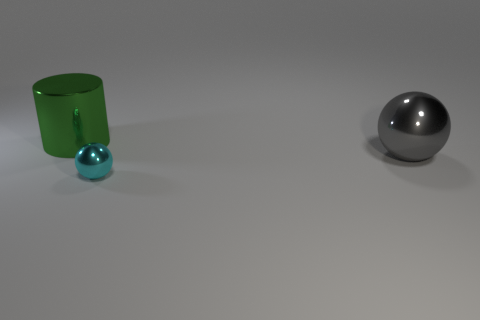Add 1 gray metal things. How many objects exist? 4 Subtract all cylinders. How many objects are left? 2 Subtract 0 gray blocks. How many objects are left? 3 Subtract 2 spheres. How many spheres are left? 0 Subtract all red spheres. Subtract all brown cylinders. How many spheres are left? 2 Subtract all brown cylinders. How many cyan balls are left? 1 Subtract all small green metallic balls. Subtract all tiny cyan objects. How many objects are left? 2 Add 3 big green cylinders. How many big green cylinders are left? 4 Add 2 big red spheres. How many big red spheres exist? 2 